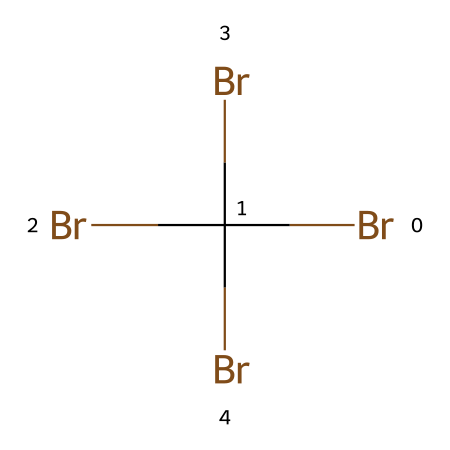What is the total number of bromine atoms in this chemical? The SMILES representation shows "BrC(Br)(Br)Br", which indicates there are four bromine (Br) atoms present in total as it includes one connected to carbon and three as substituents.
Answer: four How many carbon atoms does this chemical contain? The SMILES representation denotes "C" which indicates there is one carbon atom present in this structure.
Answer: one What type of bonding is predominantly present in this chemical? This chemical features multiple bromine atoms bonded to a single carbon atom. The nature of these bonds is covalent, common among nonmetals like carbon and bromine.
Answer: covalent Is this chemical a halogenated compound? The presence of multiple bromine atoms directly connected to a carbon atom classifies this structure as a halogenated compound.
Answer: yes What is the degree of bromination in this compound? The structure allows for direct identification of four bromine atoms bonded to a single carbon, indicating the degree of bromination is high at four.
Answer: four Can this chemical serve as a flame retardant? Given that bromine is renowned for its efficacy in flame retardants due to its ability to inhibit combustion, and the high bromination level suggests a functioning characteristic in flame retardancy.
Answer: yes 